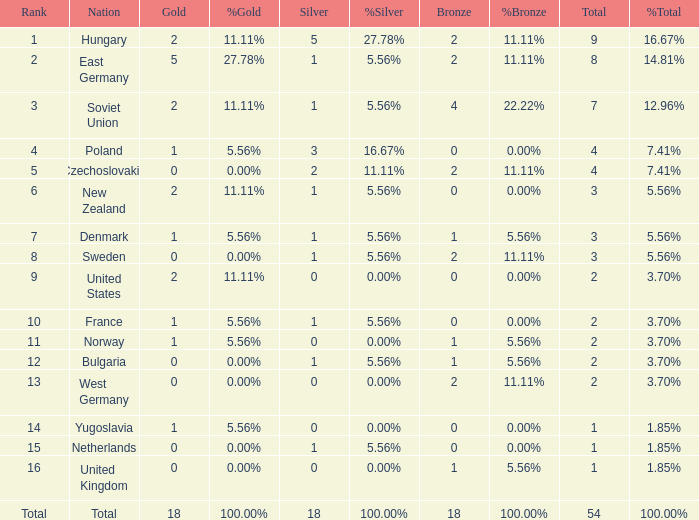What is the lowest total for those receiving less than 18 but more than 14? 1.0. 